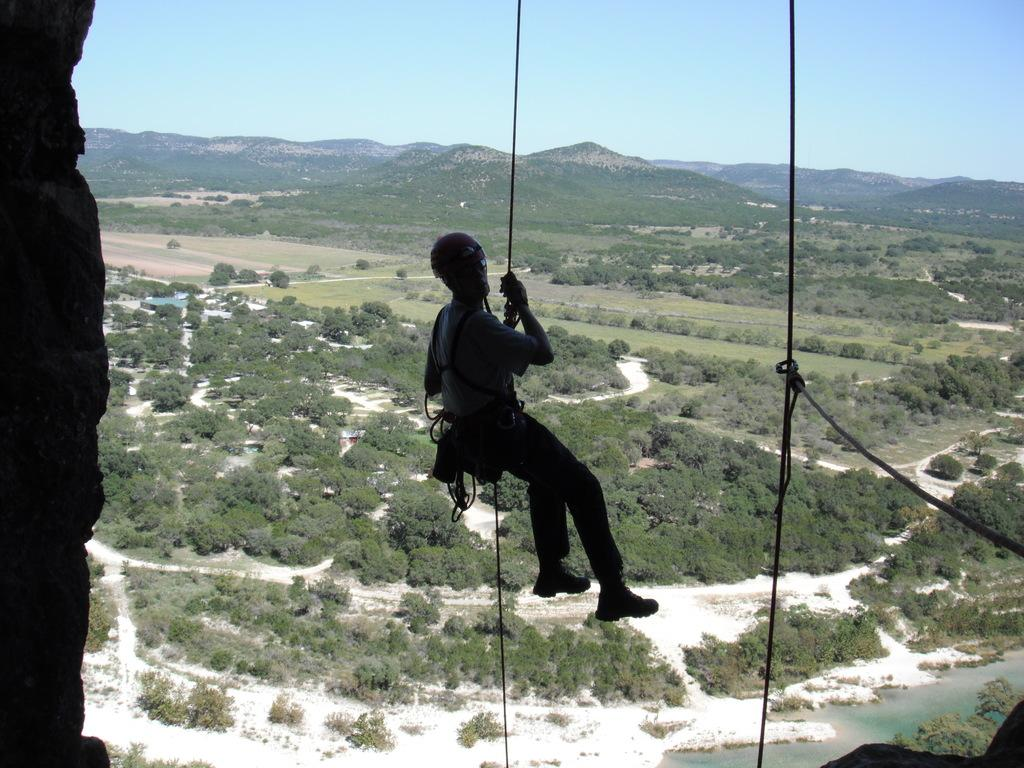What type of vegetation can be seen in the image? There are trees in the image. What is the person in the image doing? The person is hanging on a rope in the image. What type of terrain is visible in the image? There is a hill visible in the image. What is visible at the top of the image? The sky is visible at the top of the image. How many pizzas are being served on the ground in the image? There are no pizzas or ground present in the image. What is the sun doing in the image? The sun is not visible in the image; only the sky is visible at the top. 